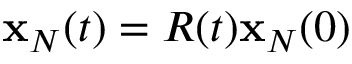Convert formula to latex. <formula><loc_0><loc_0><loc_500><loc_500>{ x } _ { N } ( t ) = R ( t ) { x } _ { N } ( 0 )</formula> 